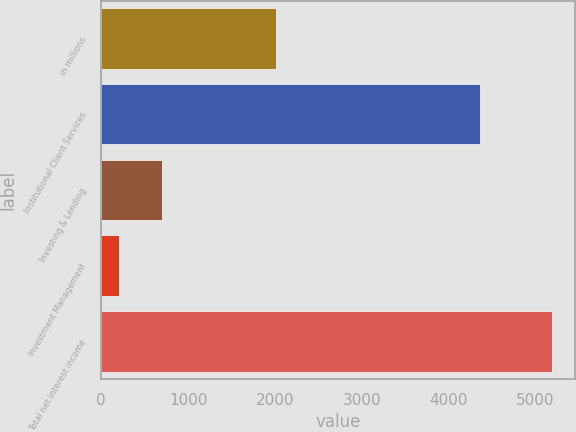Convert chart to OTSL. <chart><loc_0><loc_0><loc_500><loc_500><bar_chart><fcel>in millions<fcel>Institutional Client Services<fcel>Investing & Lending<fcel>Investment Management<fcel>Total net interest income<nl><fcel>2011<fcel>4360<fcel>701.9<fcel>203<fcel>5192<nl></chart> 